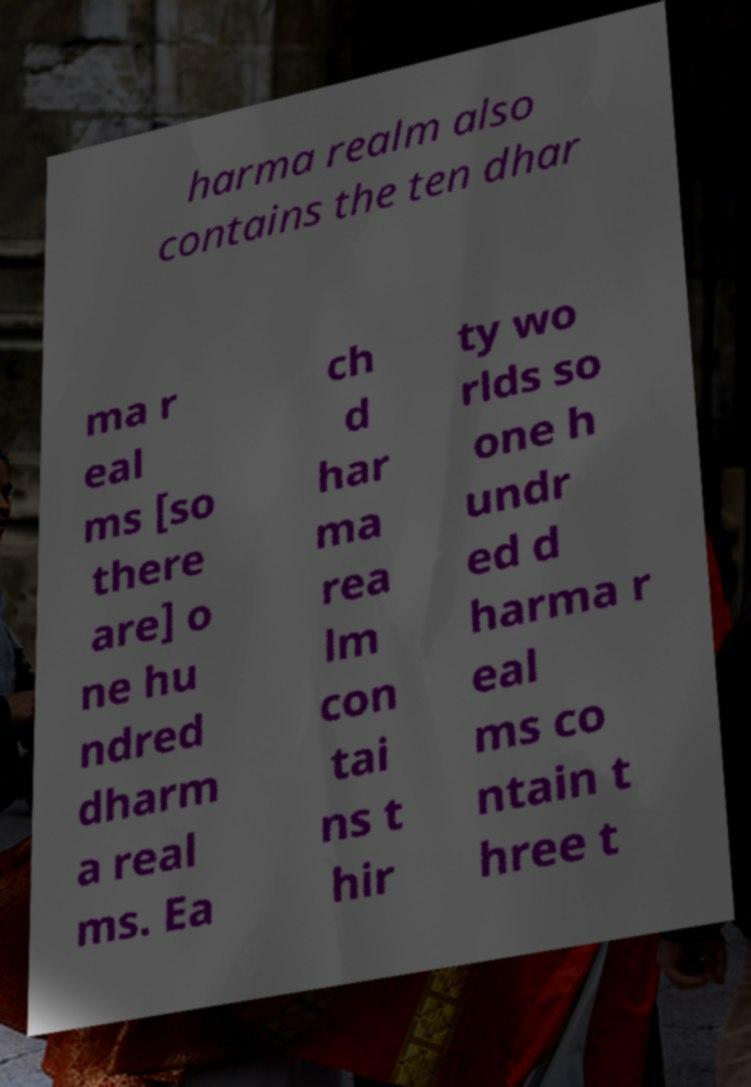Could you extract and type out the text from this image? harma realm also contains the ten dhar ma r eal ms [so there are] o ne hu ndred dharm a real ms. Ea ch d har ma rea lm con tai ns t hir ty wo rlds so one h undr ed d harma r eal ms co ntain t hree t 